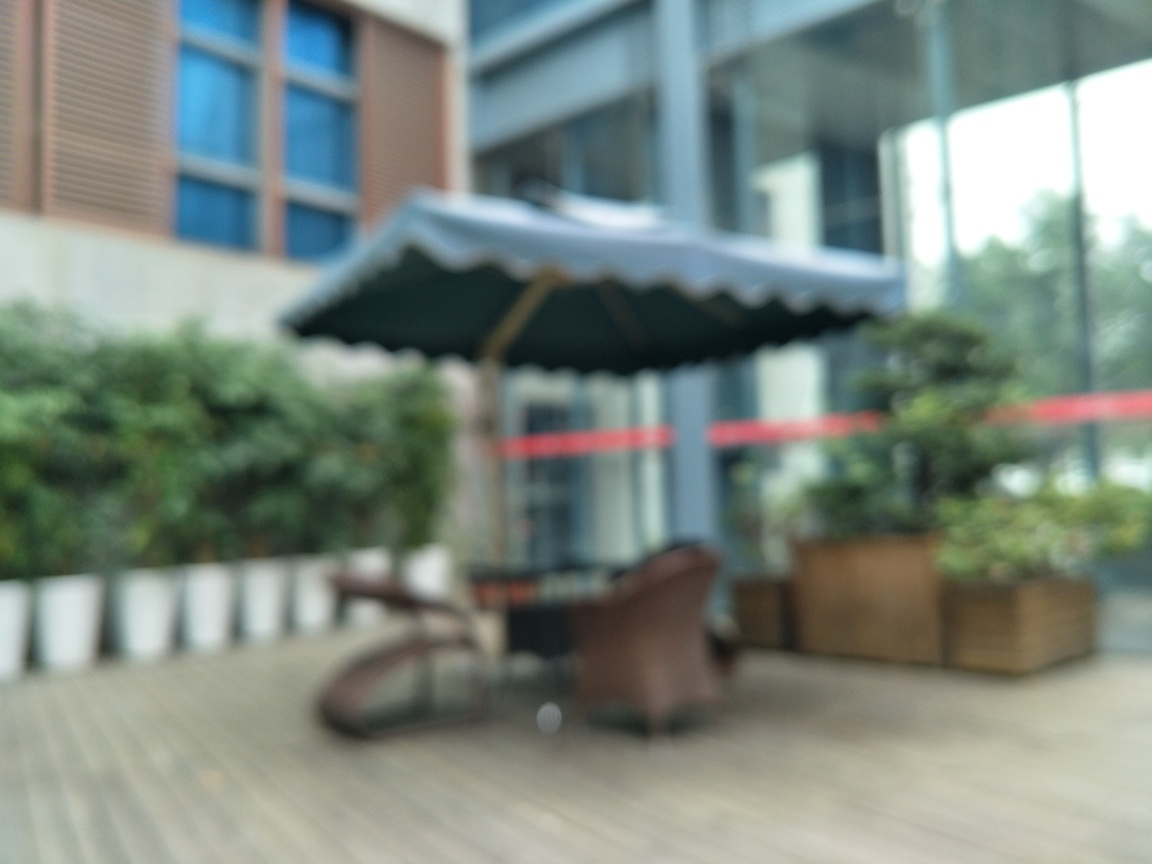Has this picture captured fine texture details? No, the image is blurred and lacks clear, fine texture details that would normally be present in a well-focused photograph. The conditions or settings that led to this photo being out of focus have prevented it from capturing crisp textures, which is vital in visualizing accurate details in a photograph. 